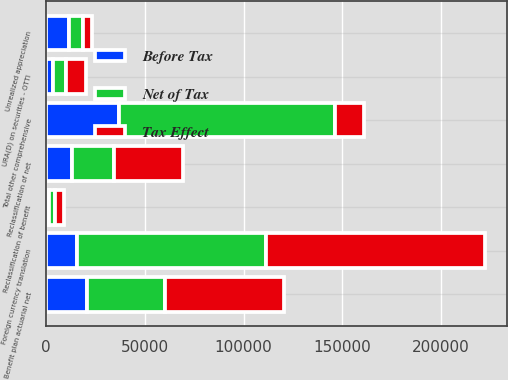Convert chart. <chart><loc_0><loc_0><loc_500><loc_500><stacked_bar_chart><ecel><fcel>Unrealized appreciation<fcel>URA(D) on securities - OTTI<fcel>Reclassification of net<fcel>Foreign currency translation<fcel>Benefit plan actuarial net<fcel>Reclassification of benefit<fcel>Total other comprehensive<nl><fcel>Tax Effect<fcel>4278<fcel>10078<fcel>34668<fcel>111145<fcel>60169<fcel>4647<fcel>14502<nl><fcel>Before Tax<fcel>11653<fcel>3407<fcel>13276<fcel>15728<fcel>21059<fcel>1627<fcel>36944<nl><fcel>Net of Tax<fcel>7375<fcel>6671<fcel>21392<fcel>95417<fcel>39110<fcel>3020<fcel>109411<nl></chart> 